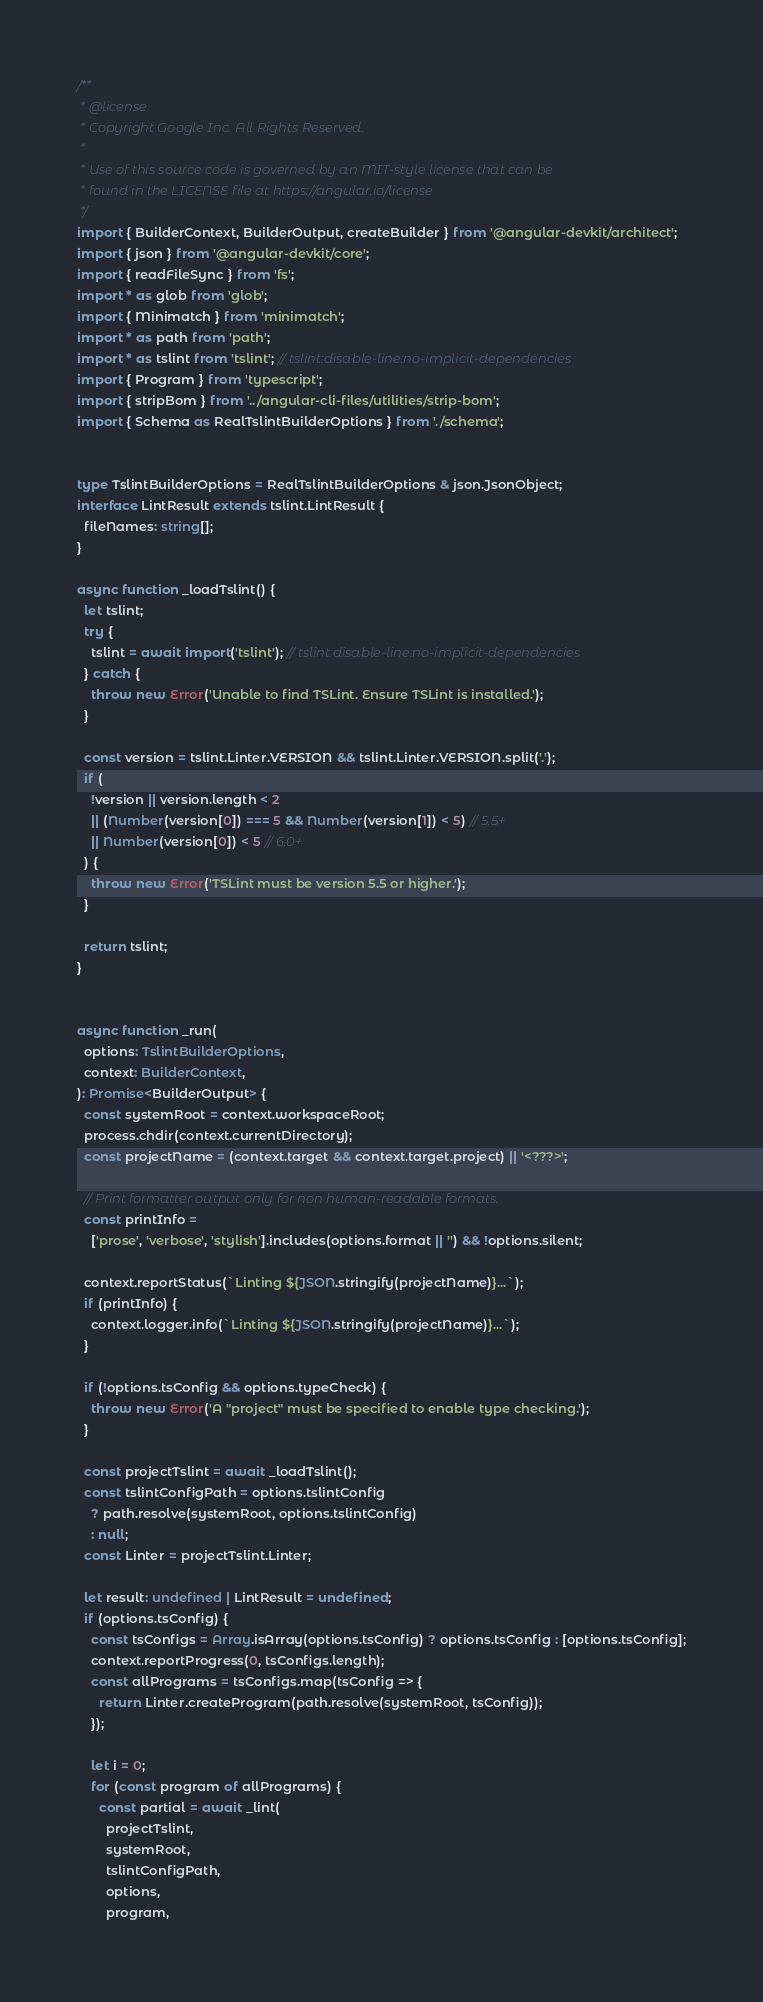Convert code to text. <code><loc_0><loc_0><loc_500><loc_500><_TypeScript_>/**
 * @license
 * Copyright Google Inc. All Rights Reserved.
 *
 * Use of this source code is governed by an MIT-style license that can be
 * found in the LICENSE file at https://angular.io/license
 */
import { BuilderContext, BuilderOutput, createBuilder } from '@angular-devkit/architect';
import { json } from '@angular-devkit/core';
import { readFileSync } from 'fs';
import * as glob from 'glob';
import { Minimatch } from 'minimatch';
import * as path from 'path';
import * as tslint from 'tslint'; // tslint:disable-line:no-implicit-dependencies
import { Program } from 'typescript';
import { stripBom } from '../angular-cli-files/utilities/strip-bom';
import { Schema as RealTslintBuilderOptions } from './schema';


type TslintBuilderOptions = RealTslintBuilderOptions & json.JsonObject;
interface LintResult extends tslint.LintResult {
  fileNames: string[];
}

async function _loadTslint() {
  let tslint;
  try {
    tslint = await import('tslint'); // tslint:disable-line:no-implicit-dependencies
  } catch {
    throw new Error('Unable to find TSLint. Ensure TSLint is installed.');
  }

  const version = tslint.Linter.VERSION && tslint.Linter.VERSION.split('.');
  if (
    !version || version.length < 2
    || (Number(version[0]) === 5 && Number(version[1]) < 5) // 5.5+
    || Number(version[0]) < 5 // 6.0+
  ) {
    throw new Error('TSLint must be version 5.5 or higher.');
  }

  return tslint;
}


async function _run(
  options: TslintBuilderOptions,
  context: BuilderContext,
): Promise<BuilderOutput> {
  const systemRoot = context.workspaceRoot;
  process.chdir(context.currentDirectory);
  const projectName = (context.target && context.target.project) || '<???>';

  // Print formatter output only for non human-readable formats.
  const printInfo =
    ['prose', 'verbose', 'stylish'].includes(options.format || '') && !options.silent;

  context.reportStatus(`Linting ${JSON.stringify(projectName)}...`);
  if (printInfo) {
    context.logger.info(`Linting ${JSON.stringify(projectName)}...`);
  }

  if (!options.tsConfig && options.typeCheck) {
    throw new Error('A "project" must be specified to enable type checking.');
  }

  const projectTslint = await _loadTslint();
  const tslintConfigPath = options.tslintConfig
    ? path.resolve(systemRoot, options.tslintConfig)
    : null;
  const Linter = projectTslint.Linter;

  let result: undefined | LintResult = undefined;
  if (options.tsConfig) {
    const tsConfigs = Array.isArray(options.tsConfig) ? options.tsConfig : [options.tsConfig];
    context.reportProgress(0, tsConfigs.length);
    const allPrograms = tsConfigs.map(tsConfig => {
      return Linter.createProgram(path.resolve(systemRoot, tsConfig));
    });

    let i = 0;
    for (const program of allPrograms) {
      const partial = await _lint(
        projectTslint,
        systemRoot,
        tslintConfigPath,
        options,
        program,</code> 